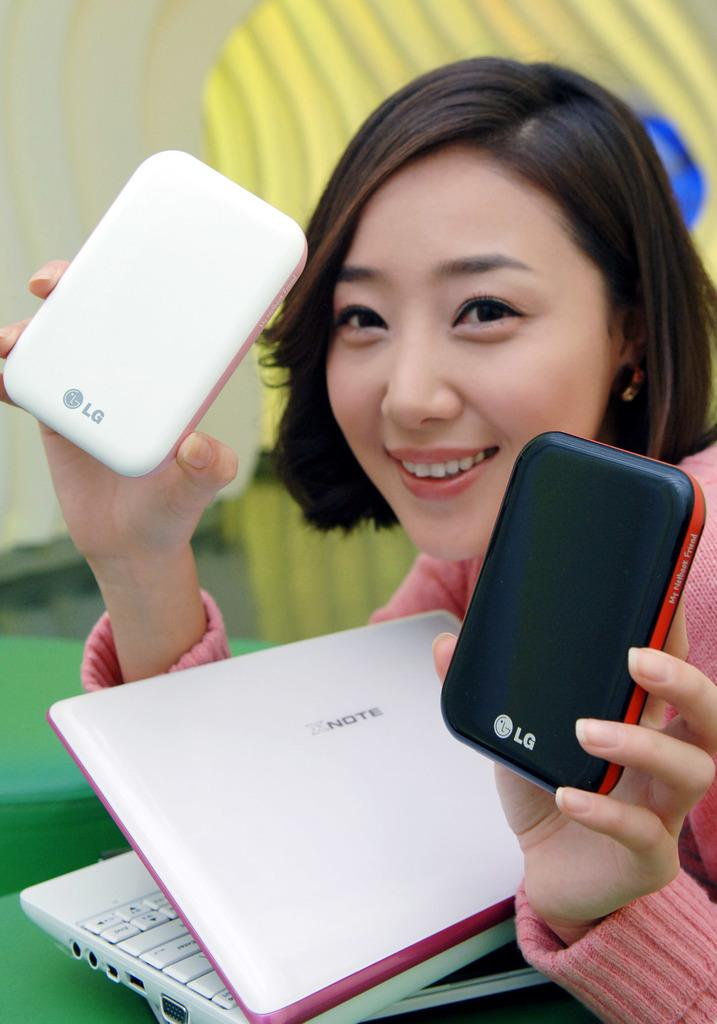Provide a one-sentence caption for the provided image. A young woman in a pink sweater holds an electronic device in each hand, one black and one white, each bearing the LG product symbol. 